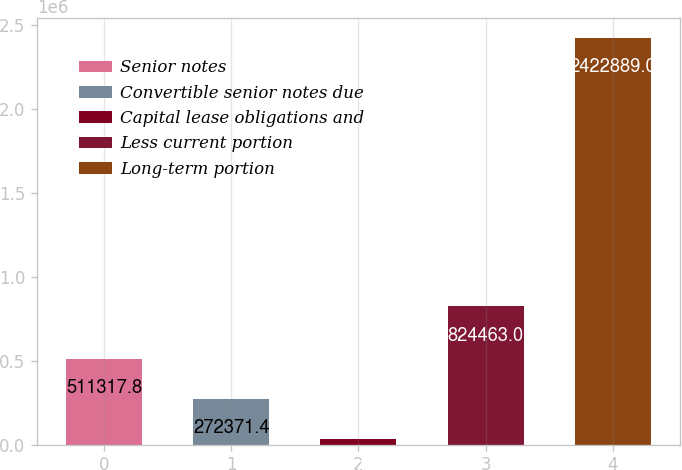Convert chart to OTSL. <chart><loc_0><loc_0><loc_500><loc_500><bar_chart><fcel>Senior notes<fcel>Convertible senior notes due<fcel>Capital lease obligations and<fcel>Less current portion<fcel>Long-term portion<nl><fcel>511318<fcel>272371<fcel>33425<fcel>824463<fcel>2.42289e+06<nl></chart> 